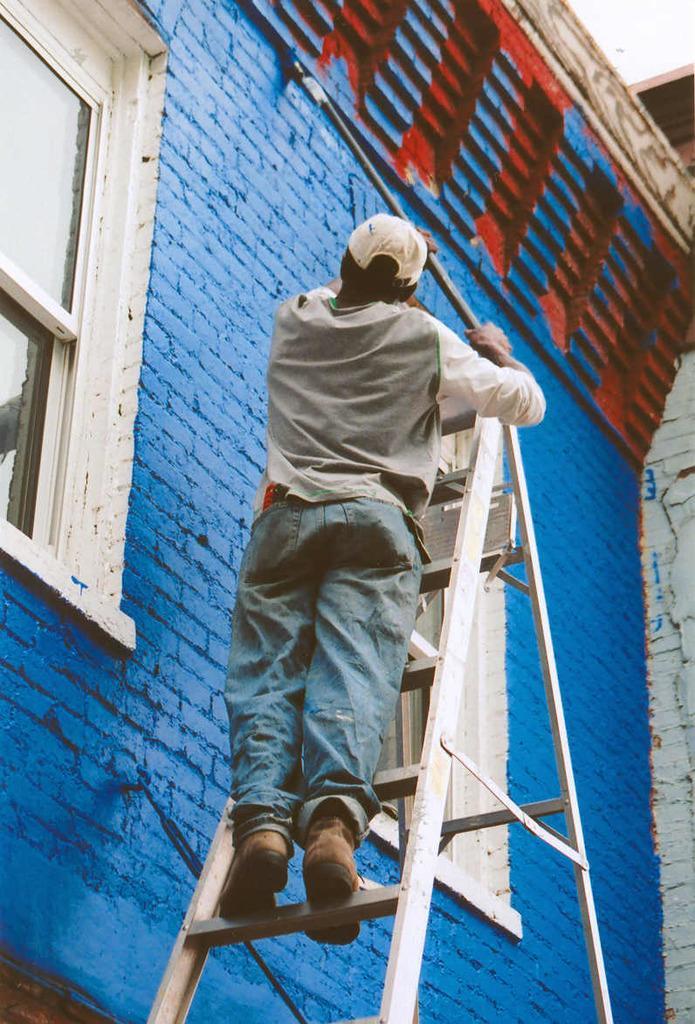Can you describe this image briefly? In this image we can see a person, ladder and other objects. In the background of the image there is a wall, windows and other objects. On the right side top of the image there is the sky. 